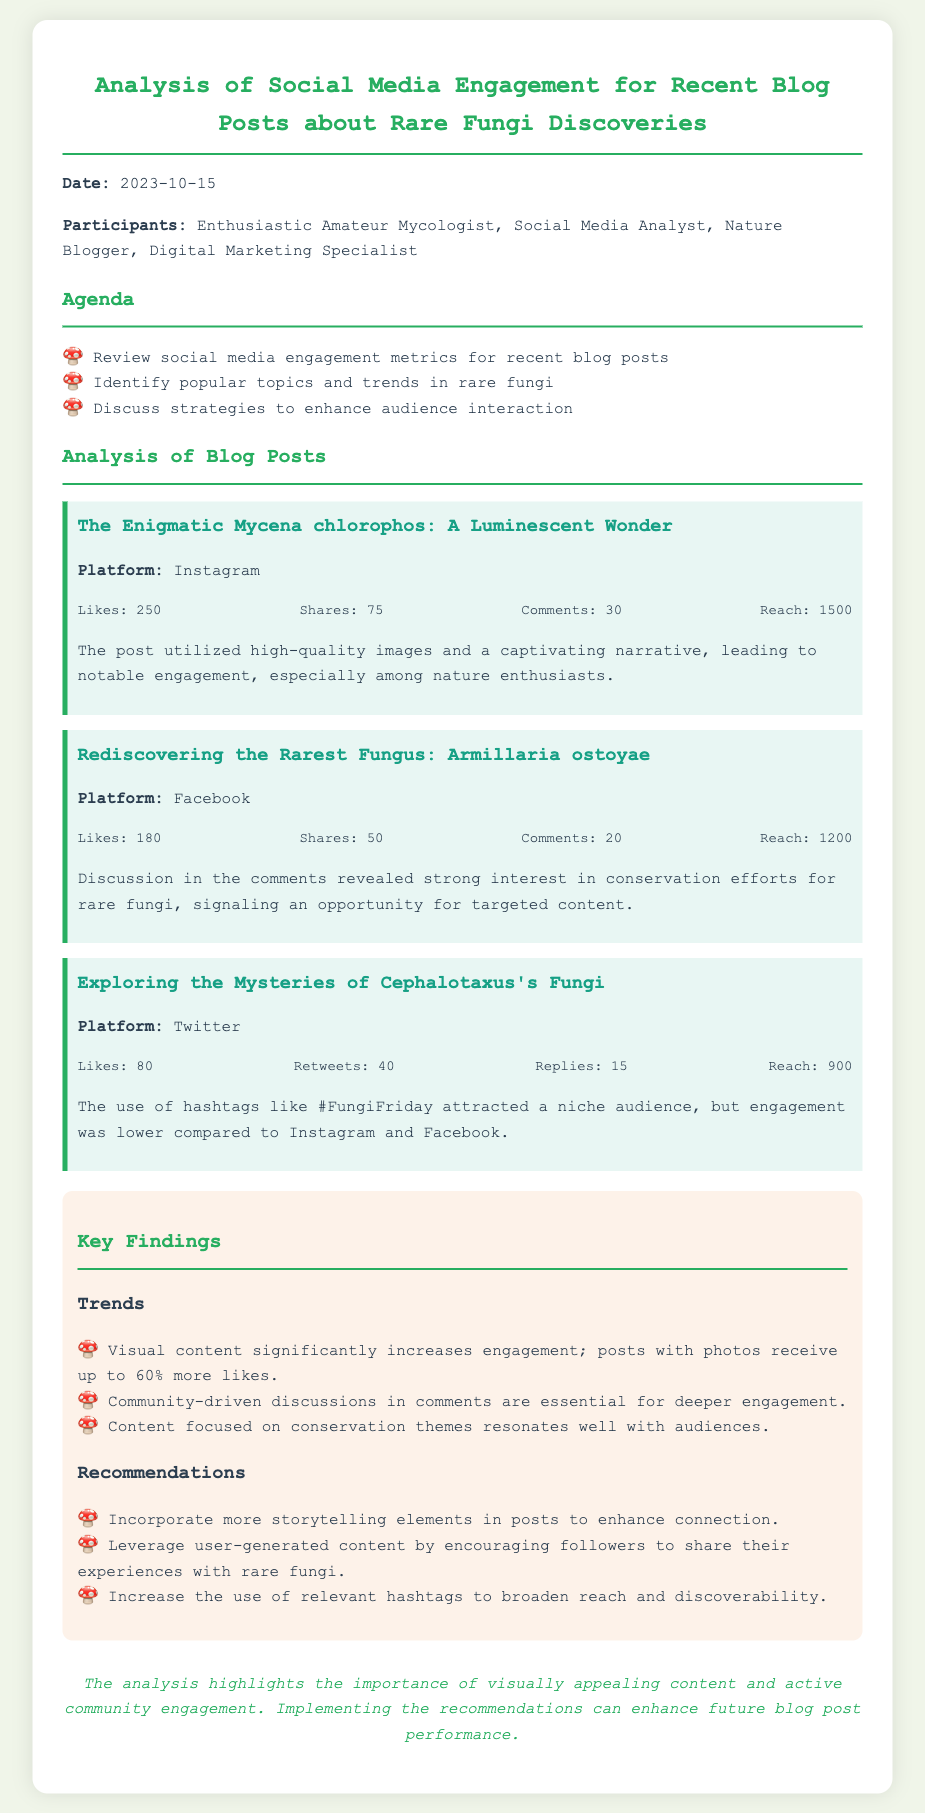What is the date of the meeting? The date of the meeting is mentioned at the beginning of the document as "2023-10-15."
Answer: 2023-10-15 Who participated in the meeting? The participants of the meeting are listed in the document, which includes "Enthusiastic Amateur Mycologist, Social Media Analyst, Nature Blogger, Digital Marketing Specialist."
Answer: Enthusiastic Amateur Mycologist, Social Media Analyst, Nature Blogger, Digital Marketing Specialist Which blog post received the most likes? The blog post with the highest number of likes is "The Enigmatic Mycena chlorophos: A Luminescent Wonder," which received 250 likes.
Answer: The Enigmatic Mycena chlorophos: A Luminescent Wonder What was the reach of the Rediscovering the Rarest Fungus post? The reach for "Rediscovering the Rarest Fungus: Armillaria ostoyae" is specified in the document as 1200.
Answer: 1200 What engagement metric is lower for the Twitter post? The document states that engagement for the Twitter post was lower compared to Instagram and Facebook, specifically for the number of likes.
Answer: Likes What strategy is recommended to enhance audience interaction? The document provides several strategies, one of which is to "Incorporate more storytelling elements in posts to enhance connection."
Answer: Incorporate more storytelling elements in posts How did the use of hashtags impact the Twitter post? The document indicates that the use of hashtags like #FungiFriday attracted a niche audience.
Answer: Attracted a niche audience What theme resonates well with the audience according to the analysis? The analysis highlights that content focused on conservation themes resonates well with audiences.
Answer: Conservation themes What visual content impact is noted in the key findings? It is noted that visual content significantly increases engagement, with posts receiving up to 60% more likes.
Answer: Up to 60% more likes 